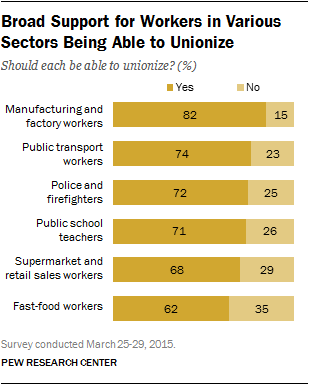Point out several critical features in this image. According to the survey, a significant percentage of police and firefighters answered 'no' to the question. There are two types of workers who answered "Yes" and their response is less than 70%. 